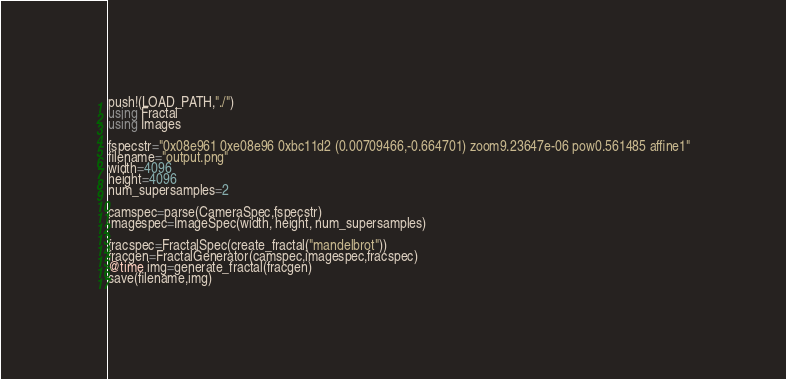Convert code to text. <code><loc_0><loc_0><loc_500><loc_500><_Julia_>push!(LOAD_PATH,"./")
using Fractal
using Images

fspecstr="0x08e961 0xe08e96 0xbc11d2 (0.00709466,-0.664701) zoom9.23647e-06 pow0.561485 affine1"
filename="output.png"
width=4096
height=4096
num_supersamples=2

camspec=parse(CameraSpec,fspecstr)
imagespec=ImageSpec(width, height, num_supersamples)

fracspec=FractalSpec(create_fractal("mandelbrot"))
fracgen=FractalGenerator(camspec,imagespec,fracspec)
@time img=generate_fractal(fracgen)
save(filename,img)
</code> 